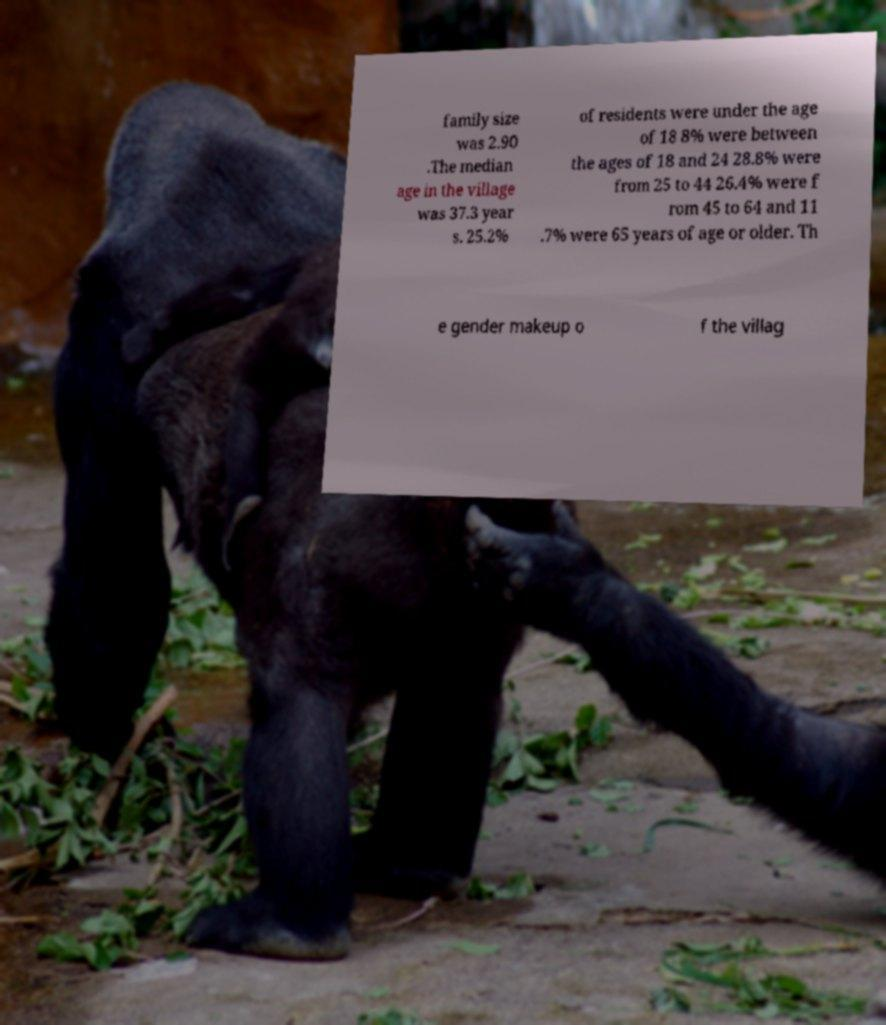Please identify and transcribe the text found in this image. family size was 2.90 .The median age in the village was 37.3 year s. 25.2% of residents were under the age of 18 8% were between the ages of 18 and 24 28.8% were from 25 to 44 26.4% were f rom 45 to 64 and 11 .7% were 65 years of age or older. Th e gender makeup o f the villag 